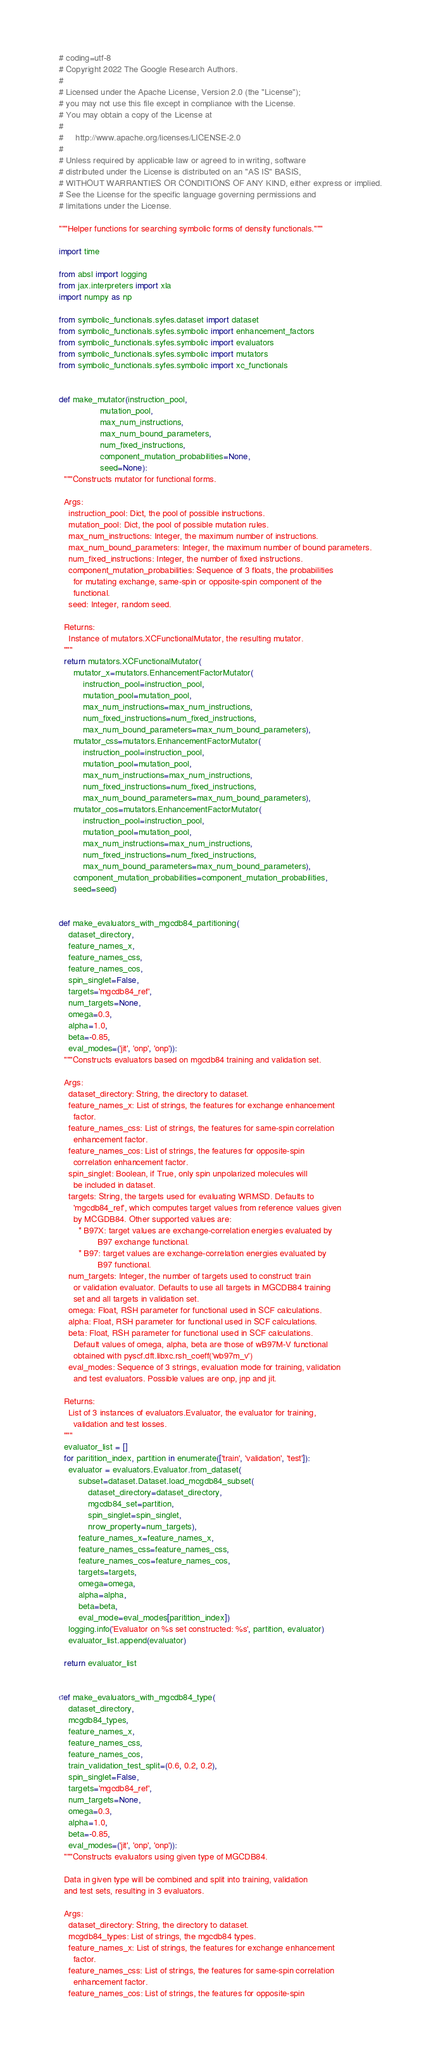<code> <loc_0><loc_0><loc_500><loc_500><_Python_># coding=utf-8
# Copyright 2022 The Google Research Authors.
#
# Licensed under the Apache License, Version 2.0 (the "License");
# you may not use this file except in compliance with the License.
# You may obtain a copy of the License at
#
#     http://www.apache.org/licenses/LICENSE-2.0
#
# Unless required by applicable law or agreed to in writing, software
# distributed under the License is distributed on an "AS IS" BASIS,
# WITHOUT WARRANTIES OR CONDITIONS OF ANY KIND, either express or implied.
# See the License for the specific language governing permissions and
# limitations under the License.

"""Helper functions for searching symbolic forms of density functionals."""

import time

from absl import logging
from jax.interpreters import xla
import numpy as np

from symbolic_functionals.syfes.dataset import dataset
from symbolic_functionals.syfes.symbolic import enhancement_factors
from symbolic_functionals.syfes.symbolic import evaluators
from symbolic_functionals.syfes.symbolic import mutators
from symbolic_functionals.syfes.symbolic import xc_functionals


def make_mutator(instruction_pool,
                 mutation_pool,
                 max_num_instructions,
                 max_num_bound_parameters,
                 num_fixed_instructions,
                 component_mutation_probabilities=None,
                 seed=None):
  """Constructs mutator for functional forms.

  Args:
    instruction_pool: Dict, the pool of possible instructions.
    mutation_pool: Dict, the pool of possible mutation rules.
    max_num_instructions: Integer, the maximum number of instructions.
    max_num_bound_parameters: Integer, the maximum number of bound parameters.
    num_fixed_instructions: Integer, the number of fixed instructions.
    component_mutation_probabilities: Sequence of 3 floats, the probabilities
      for mutating exchange, same-spin or opposite-spin component of the
      functional.
    seed: Integer, random seed.

  Returns:
    Instance of mutators.XCFunctionalMutator, the resulting mutator.
  """
  return mutators.XCFunctionalMutator(
      mutator_x=mutators.EnhancementFactorMutator(
          instruction_pool=instruction_pool,
          mutation_pool=mutation_pool,
          max_num_instructions=max_num_instructions,
          num_fixed_instructions=num_fixed_instructions,
          max_num_bound_parameters=max_num_bound_parameters),
      mutator_css=mutators.EnhancementFactorMutator(
          instruction_pool=instruction_pool,
          mutation_pool=mutation_pool,
          max_num_instructions=max_num_instructions,
          num_fixed_instructions=num_fixed_instructions,
          max_num_bound_parameters=max_num_bound_parameters),
      mutator_cos=mutators.EnhancementFactorMutator(
          instruction_pool=instruction_pool,
          mutation_pool=mutation_pool,
          max_num_instructions=max_num_instructions,
          num_fixed_instructions=num_fixed_instructions,
          max_num_bound_parameters=max_num_bound_parameters),
      component_mutation_probabilities=component_mutation_probabilities,
      seed=seed)


def make_evaluators_with_mgcdb84_partitioning(
    dataset_directory,
    feature_names_x,
    feature_names_css,
    feature_names_cos,
    spin_singlet=False,
    targets='mgcdb84_ref',
    num_targets=None,
    omega=0.3,
    alpha=1.0,
    beta=-0.85,
    eval_modes=('jit', 'onp', 'onp')):
  """Constructs evaluators based on mgcdb84 training and validation set.

  Args:
    dataset_directory: String, the directory to dataset.
    feature_names_x: List of strings, the features for exchange enhancement
      factor.
    feature_names_css: List of strings, the features for same-spin correlation
      enhancement factor.
    feature_names_cos: List of strings, the features for opposite-spin
      correlation enhancement factor.
    spin_singlet: Boolean, if True, only spin unpolarized molecules will
      be included in dataset.
    targets: String, the targets used for evaluating WRMSD. Defaults to
      'mgcdb84_ref', which computes target values from reference values given
      by MCGDB84. Other supported values are:
        * B97X: target values are exchange-correlation energies evaluated by
                B97 exchange functional.
        * B97: target values are exchange-correlation energies evaluated by
                B97 functional.
    num_targets: Integer, the number of targets used to construct train
      or validation evaluator. Defaults to use all targets in MGCDB84 training
      set and all targets in validation set.
    omega: Float, RSH parameter for functional used in SCF calculations.
    alpha: Float, RSH parameter for functional used in SCF calculations.
    beta: Float, RSH parameter for functional used in SCF calculations.
      Default values of omega, alpha, beta are those of wB97M-V functional
      obtained with pyscf.dft.libxc.rsh_coeff('wb97m_v')
    eval_modes: Sequence of 3 strings, evaluation mode for training, validation
      and test evaluators. Possible values are onp, jnp and jit.

  Returns:
    List of 3 instances of evaluators.Evaluator, the evaluator for training,
      validation and test losses.
  """
  evaluator_list = []
  for paritition_index, partition in enumerate(['train', 'validation', 'test']):
    evaluator = evaluators.Evaluator.from_dataset(
        subset=dataset.Dataset.load_mcgdb84_subset(
            dataset_directory=dataset_directory,
            mgcdb84_set=partition,
            spin_singlet=spin_singlet,
            nrow_property=num_targets),
        feature_names_x=feature_names_x,
        feature_names_css=feature_names_css,
        feature_names_cos=feature_names_cos,
        targets=targets,
        omega=omega,
        alpha=alpha,
        beta=beta,
        eval_mode=eval_modes[paritition_index])
    logging.info('Evaluator on %s set constructed: %s', partition, evaluator)
    evaluator_list.append(evaluator)

  return evaluator_list


def make_evaluators_with_mgcdb84_type(
    dataset_directory,
    mcgdb84_types,
    feature_names_x,
    feature_names_css,
    feature_names_cos,
    train_validation_test_split=(0.6, 0.2, 0.2),
    spin_singlet=False,
    targets='mgcdb84_ref',
    num_targets=None,
    omega=0.3,
    alpha=1.0,
    beta=-0.85,
    eval_modes=('jit', 'onp', 'onp')):
  """Constructs evaluators using given type of MGCDB84.

  Data in given type will be combined and split into training, validation
  and test sets, resulting in 3 evaluators.

  Args:
    dataset_directory: String, the directory to dataset.
    mcgdb84_types: List of strings, the mgcdb84 types.
    feature_names_x: List of strings, the features for exchange enhancement
      factor.
    feature_names_css: List of strings, the features for same-spin correlation
      enhancement factor.
    feature_names_cos: List of strings, the features for opposite-spin</code> 